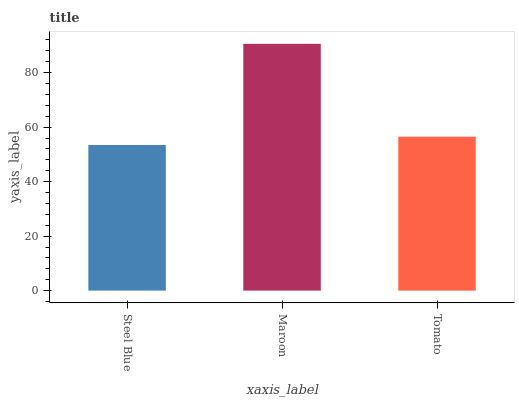Is Tomato the minimum?
Answer yes or no. No. Is Tomato the maximum?
Answer yes or no. No. Is Maroon greater than Tomato?
Answer yes or no. Yes. Is Tomato less than Maroon?
Answer yes or no. Yes. Is Tomato greater than Maroon?
Answer yes or no. No. Is Maroon less than Tomato?
Answer yes or no. No. Is Tomato the high median?
Answer yes or no. Yes. Is Tomato the low median?
Answer yes or no. Yes. Is Steel Blue the high median?
Answer yes or no. No. Is Steel Blue the low median?
Answer yes or no. No. 